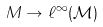Convert formula to latex. <formula><loc_0><loc_0><loc_500><loc_500>M \to \ell ^ { \infty } ( { \mathcal { M } } )</formula> 